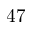<formula> <loc_0><loc_0><loc_500><loc_500>4 7</formula> 